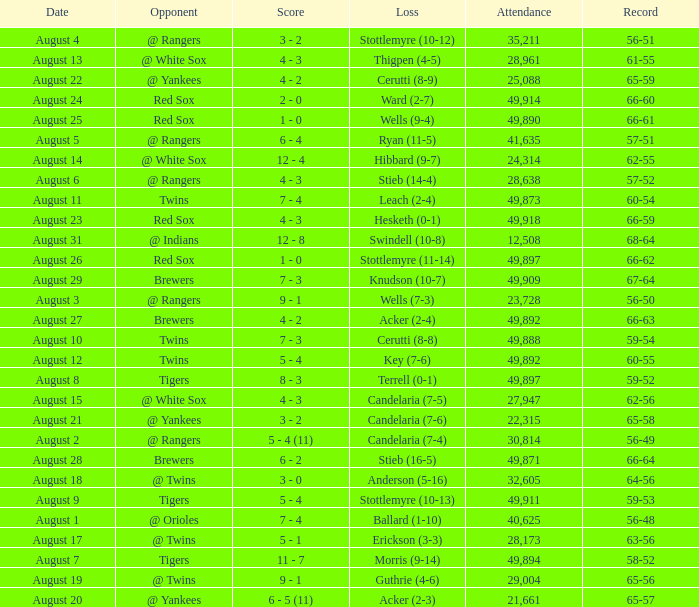What was the record of the game that had a loss of Stottlemyre (10-12)? 56-51. 